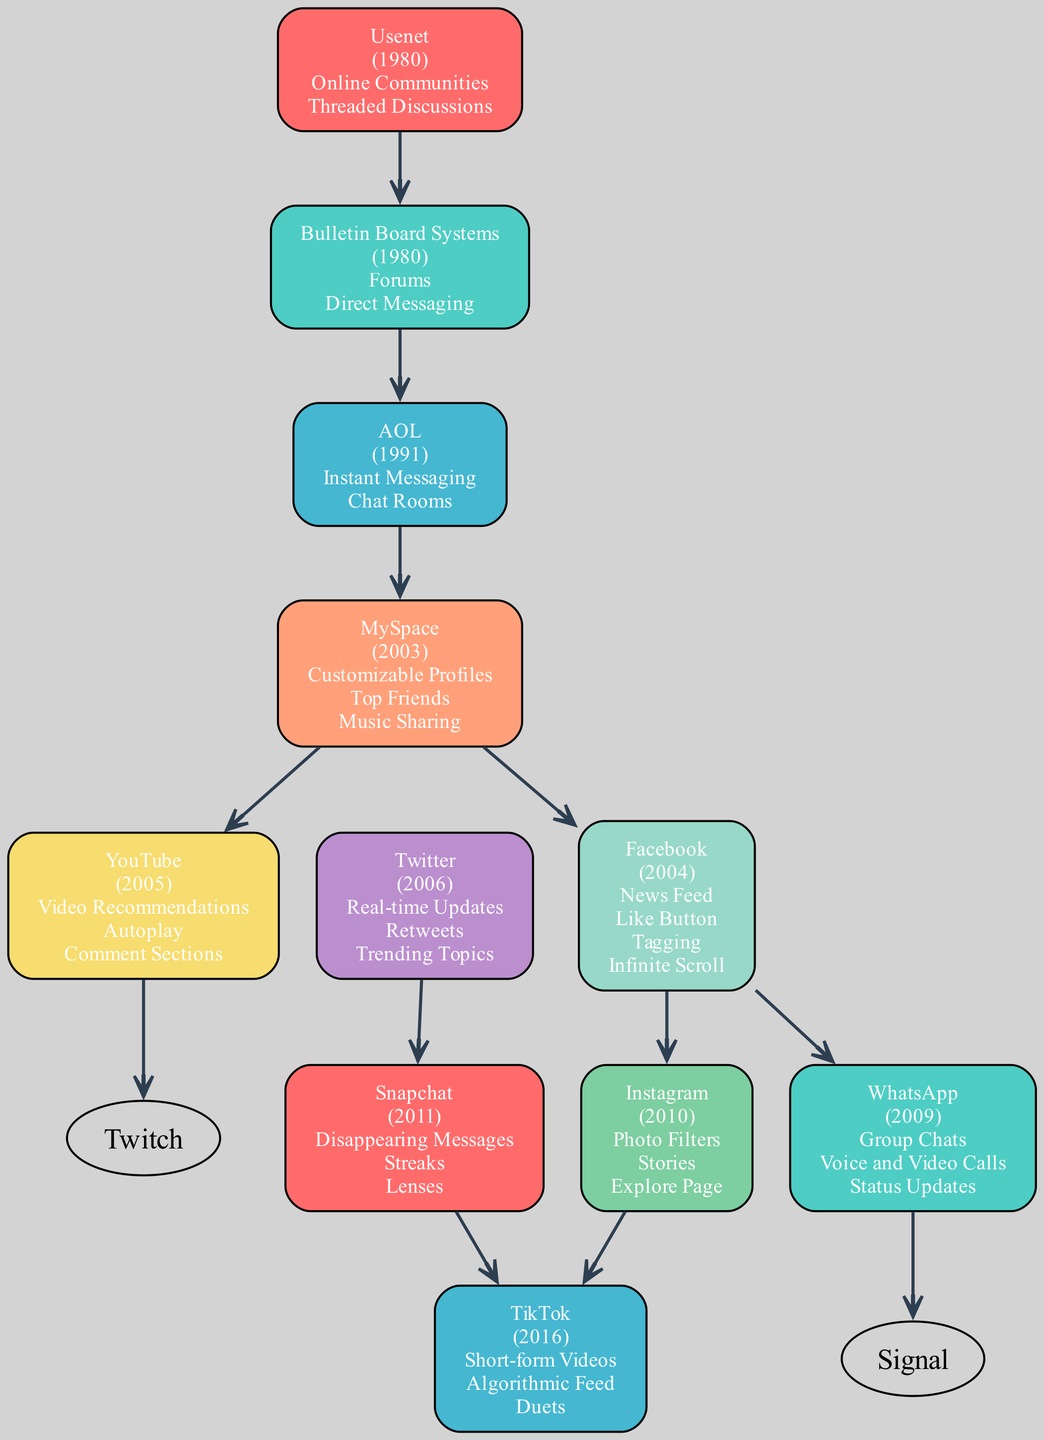What year was MySpace launched? MySpace is listed in the diagram with the launch year specified next to its name. By checking the name and year, we find that MySpace was launched in 2003.
Answer: 2003 Which platform introduced the feature of customizable profiles? The diagram specifies that MySpace has the feature of customizable profiles listed under its details. Therefore, MySpace is the platform that introduced this feature.
Answer: MySpace How many successors does Facebook have? To answer this, we can look at the number of platforms listed as successors under Facebook. The diagram shows that Facebook has two successors (Instagram and WhatsApp).
Answer: 2 What addictive feature is unique to TikTok? TikTok is depicted in the diagram with several addictive features. By examining the list, "Short-form Videos" is specified as a unique feature of TikTok.
Answer: Short-form Videos Which platform came directly after Twitter in the evolutionary chain? The diagram shows that Twitter has one successor listed, which is Snapchat. Therefore, Snapchat comes directly after Twitter.
Answer: Snapchat Which platform was launched in the year 2004? The diagram indicates the launch years next to each platform. By scanning the list, we see that Facebook was launched in 2004.
Answer: Facebook What is the primary addictive feature introduced by AOL? The diagram identifies various addictive features for AOL, including Instant Messaging and Chat Rooms. Instant Messaging is often viewed as the primary feature that defines AOL's usage.
Answer: Instant Messaging How does the feature of infinite scroll relate to Facebook? The diagram features infinite scroll listed under Facebook's addictive features, indicating that it is a characteristic feature of Facebook, contributing to its addictive nature.
Answer: Infinite Scroll What do YouTube and TikTok have in common regarding their format? Both YouTube and TikTok allow for video sharing and consumption, meaning they focus significantly on video content as a primary format, making it their commonality.
Answer: Video Content 